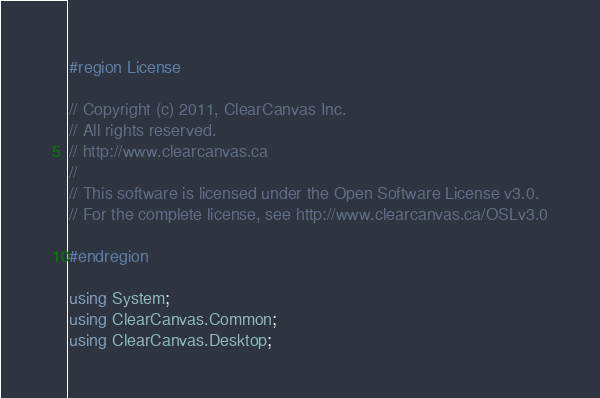<code> <loc_0><loc_0><loc_500><loc_500><_C#_>#region License

// Copyright (c) 2011, ClearCanvas Inc.
// All rights reserved.
// http://www.clearcanvas.ca
//
// This software is licensed under the Open Software License v3.0.
// For the complete license, see http://www.clearcanvas.ca/OSLv3.0

#endregion

using System;
using ClearCanvas.Common;
using ClearCanvas.Desktop;</code> 